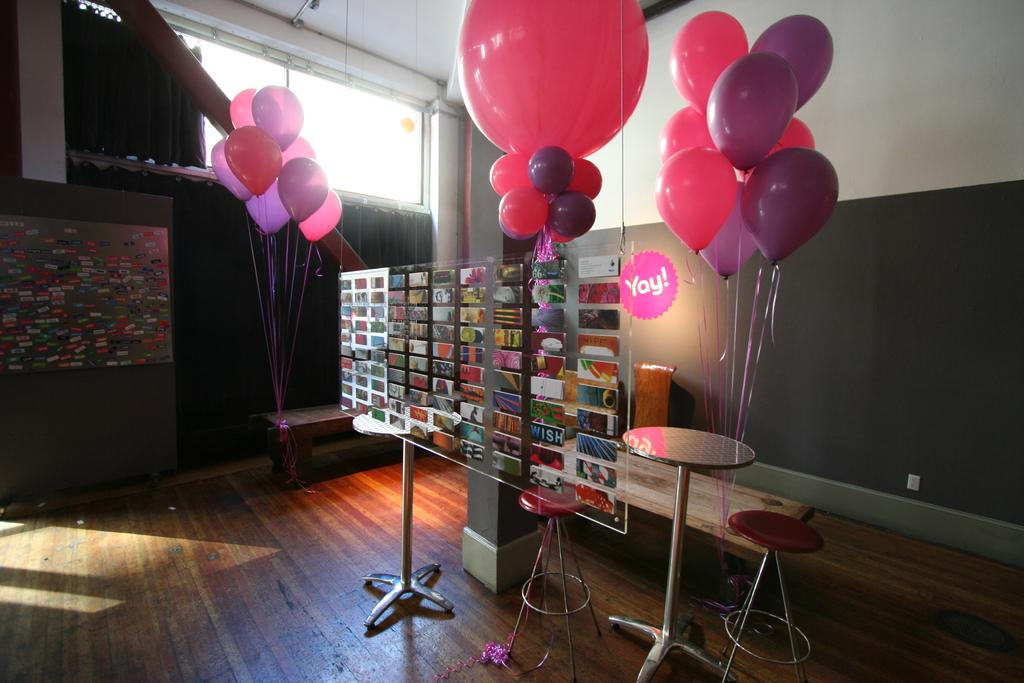<image>
Create a compact narrative representing the image presented. A pink circle that says "Yay!" is on the wall in back of some balloons. 